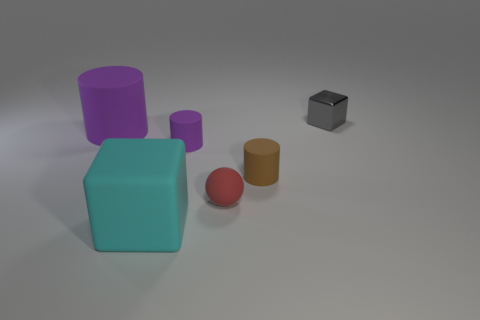Subtract all brown rubber cylinders. How many cylinders are left? 2 Add 3 small red rubber spheres. How many objects exist? 9 Subtract all brown cylinders. How many cylinders are left? 2 Subtract 1 cylinders. How many cylinders are left? 2 Subtract all blocks. How many objects are left? 4 Subtract all red cubes. How many brown cylinders are left? 1 Subtract all red cubes. Subtract all cyan spheres. How many cubes are left? 2 Subtract all gray matte cylinders. Subtract all big rubber cylinders. How many objects are left? 5 Add 5 tiny purple cylinders. How many tiny purple cylinders are left? 6 Add 5 red matte objects. How many red matte objects exist? 6 